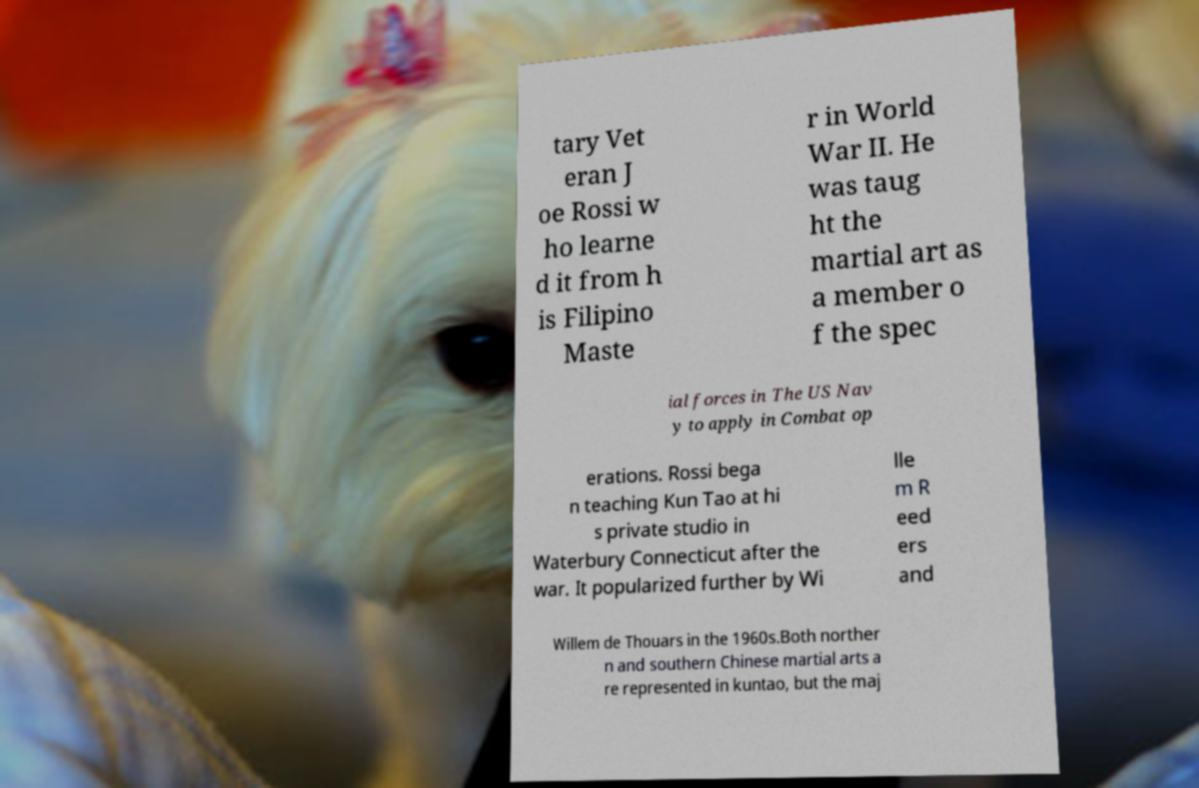There's text embedded in this image that I need extracted. Can you transcribe it verbatim? tary Vet eran J oe Rossi w ho learne d it from h is Filipino Maste r in World War II. He was taug ht the martial art as a member o f the spec ial forces in The US Nav y to apply in Combat op erations. Rossi bega n teaching Kun Tao at hi s private studio in Waterbury Connecticut after the war. It popularized further by Wi lle m R eed ers and Willem de Thouars in the 1960s.Both norther n and southern Chinese martial arts a re represented in kuntao, but the maj 